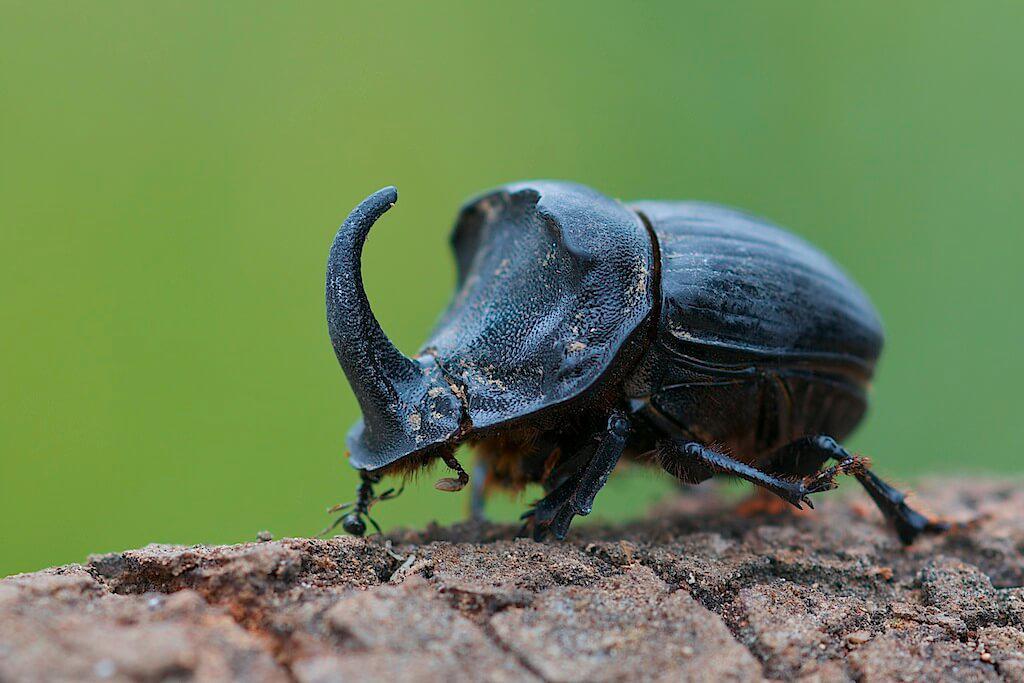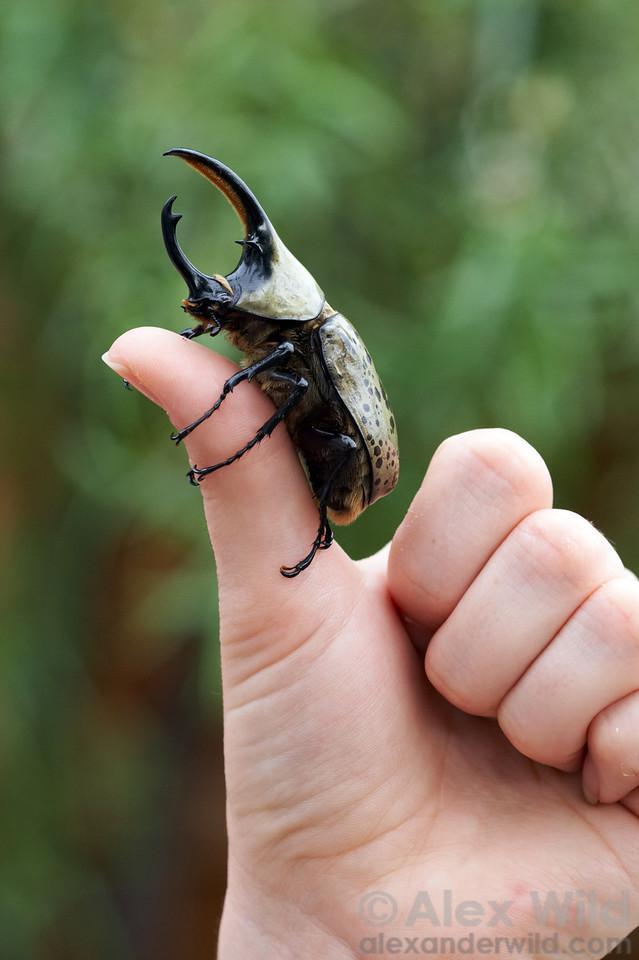The first image is the image on the left, the second image is the image on the right. Considering the images on both sides, is "An image of a beetle includes a thumb and fingers." valid? Answer yes or no. Yes. The first image is the image on the left, the second image is the image on the right. For the images shown, is this caption "The right image contains a human hand interacting with a dung beetle." true? Answer yes or no. Yes. 